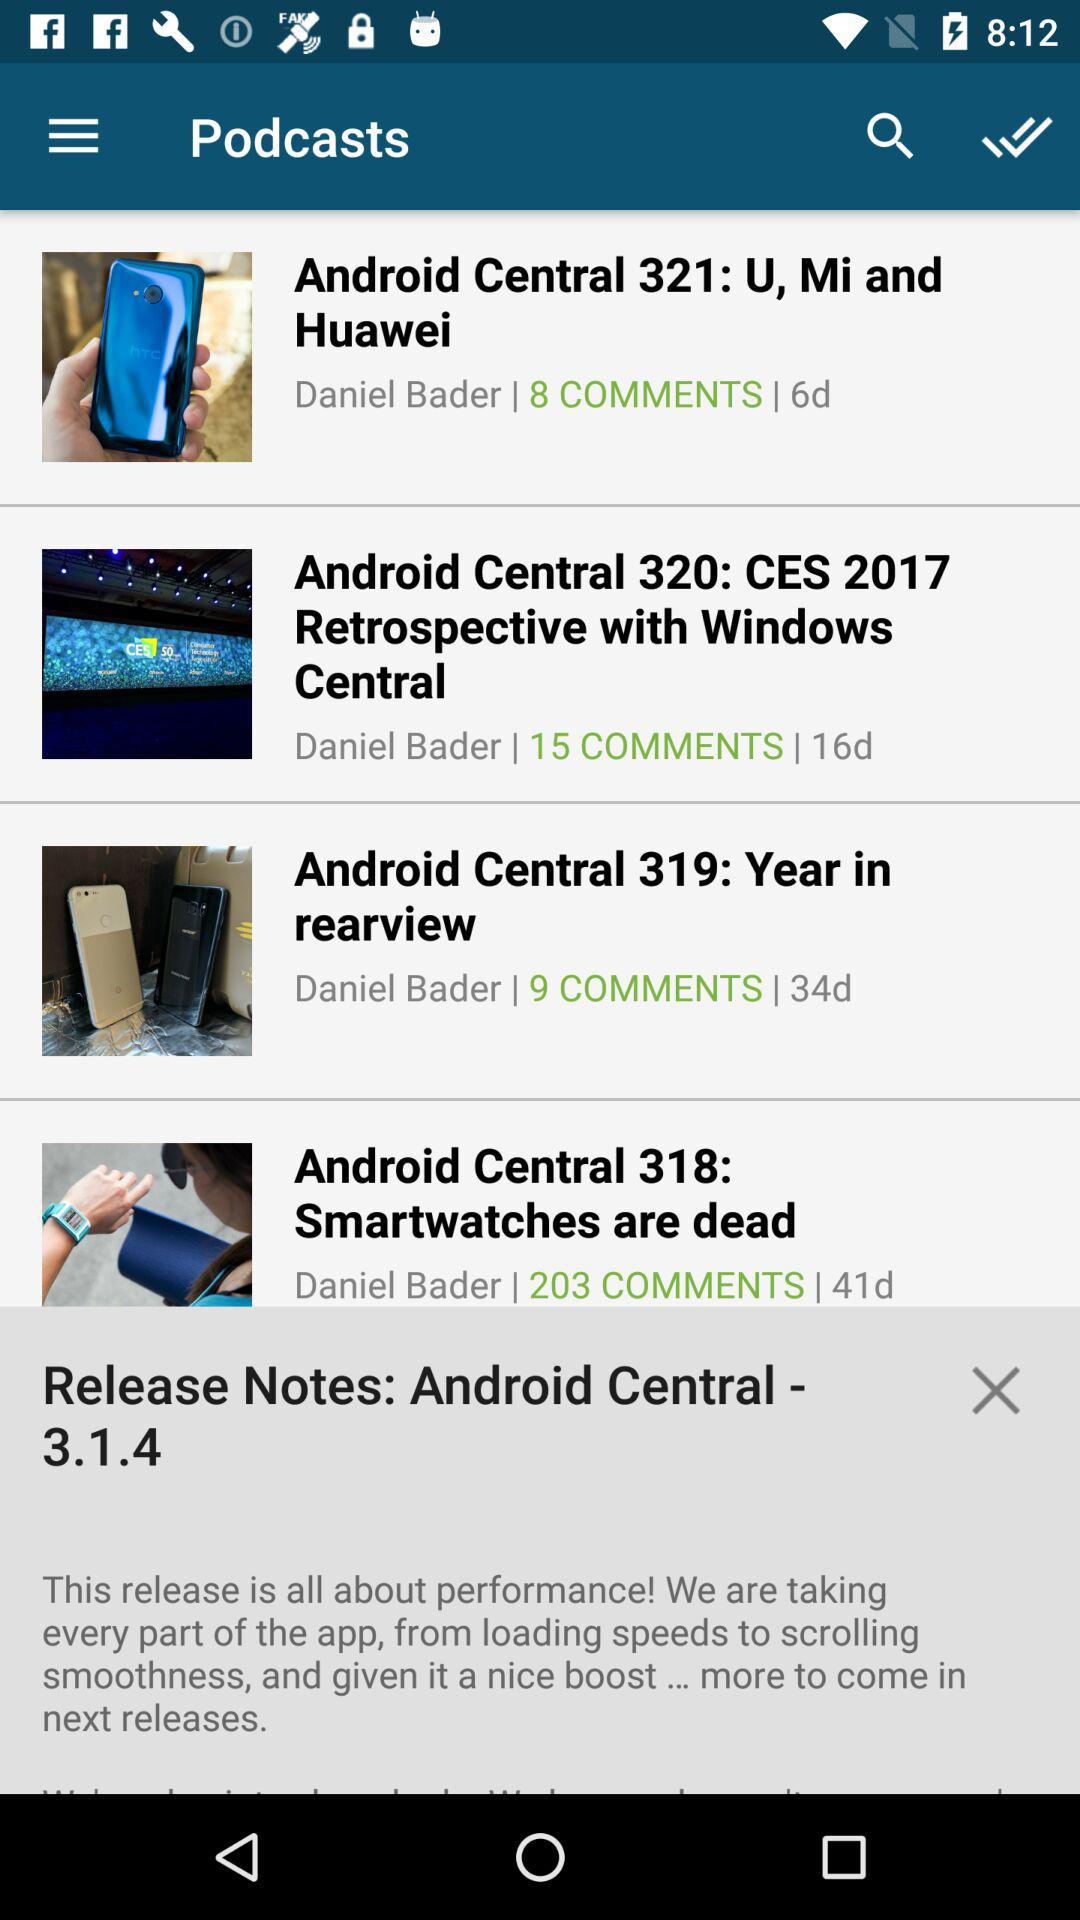How many days ago was the comment posted in "Android Central 321: U, Mi and Huawei"? The comment was posted in "Android Central 321: U, Mi and Huawei" 6 days ago. 